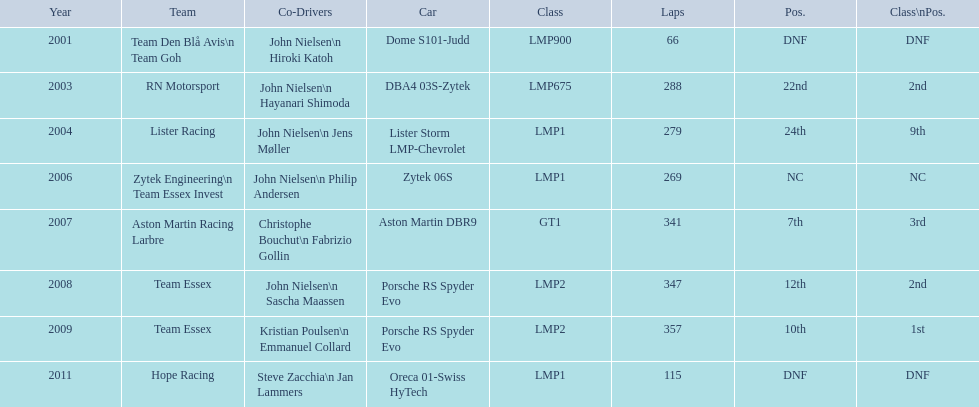Who were the co-drivers for the aston martin dbr9 in 2007? Christophe Bouchut, Fabrizio Gollin. 